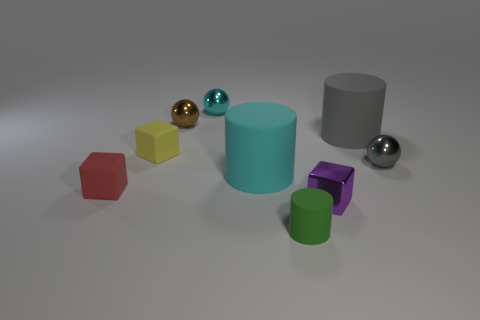Subtract all purple metallic cubes. How many cubes are left? 2 Subtract 1 blocks. How many blocks are left? 2 Add 1 gray cylinders. How many objects exist? 10 Subtract all cubes. How many objects are left? 6 Subtract all large things. Subtract all cyan balls. How many objects are left? 6 Add 6 balls. How many balls are left? 9 Add 6 shiny cubes. How many shiny cubes exist? 7 Subtract 0 purple balls. How many objects are left? 9 